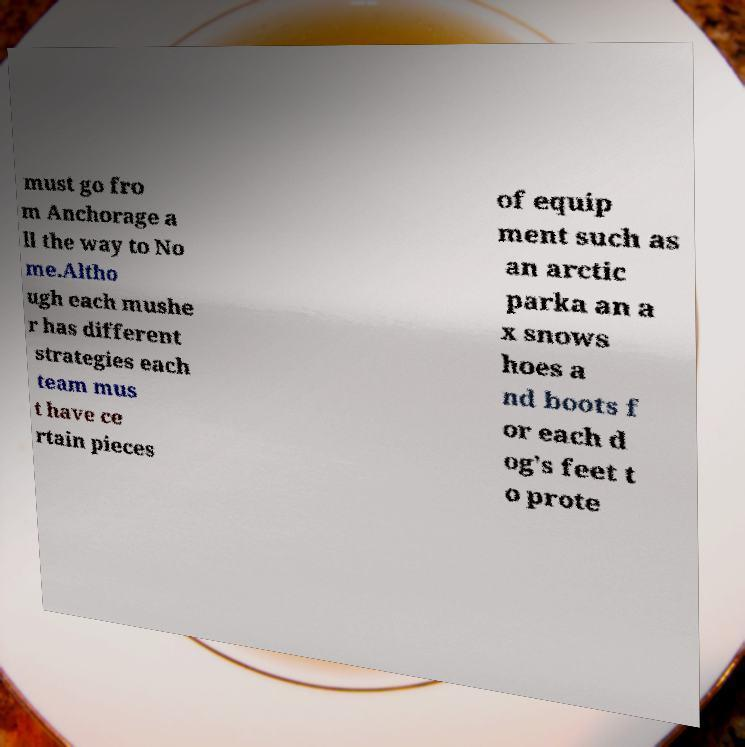There's text embedded in this image that I need extracted. Can you transcribe it verbatim? must go fro m Anchorage a ll the way to No me.Altho ugh each mushe r has different strategies each team mus t have ce rtain pieces of equip ment such as an arctic parka an a x snows hoes a nd boots f or each d og's feet t o prote 